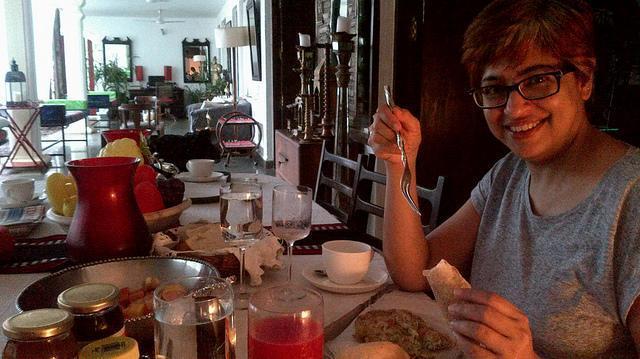How many chairs are visible?
Give a very brief answer. 2. How many bottles are there?
Give a very brief answer. 2. How many wine glasses are visible?
Give a very brief answer. 3. How many cups are there?
Give a very brief answer. 2. How many dining tables are visible?
Give a very brief answer. 1. 